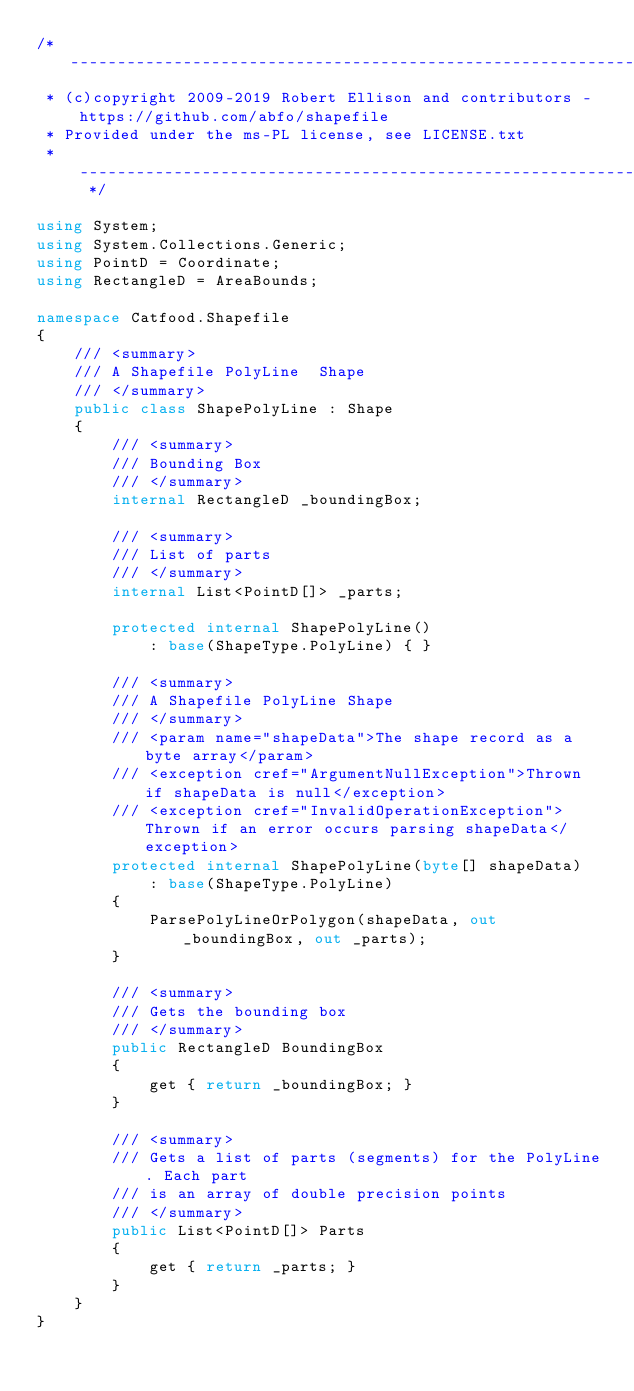Convert code to text. <code><loc_0><loc_0><loc_500><loc_500><_C#_>/* ------------------------------------------------------------------------
 * (c)copyright 2009-2019 Robert Ellison and contributors - https://github.com/abfo/shapefile
 * Provided under the ms-PL license, see LICENSE.txt
 * ------------------------------------------------------------------------ */

using System;
using System.Collections.Generic;
using PointD = Coordinate;
using RectangleD = AreaBounds;

namespace Catfood.Shapefile
{
    /// <summary>
    /// A Shapefile PolyLine  Shape
    /// </summary>
    public class ShapePolyLine : Shape
    {
        /// <summary>
        /// Bounding Box
        /// </summary>
        internal RectangleD _boundingBox;

        /// <summary>
        /// List of parts
        /// </summary>
        internal List<PointD[]> _parts;

        protected internal ShapePolyLine()
            : base(ShapeType.PolyLine) { }

        /// <summary>
        /// A Shapefile PolyLine Shape
        /// </summary>
        /// <param name="shapeData">The shape record as a byte array</param>
        /// <exception cref="ArgumentNullException">Thrown if shapeData is null</exception>
        /// <exception cref="InvalidOperationException">Thrown if an error occurs parsing shapeData</exception>
        protected internal ShapePolyLine(byte[] shapeData)
            : base(ShapeType.PolyLine)
        {
            ParsePolyLineOrPolygon(shapeData, out _boundingBox, out _parts);
        }

        /// <summary>
        /// Gets the bounding box
        /// </summary>
        public RectangleD BoundingBox
        {
            get { return _boundingBox; }
        }
        
        /// <summary>
        /// Gets a list of parts (segments) for the PolyLine. Each part
        /// is an array of double precision points
        /// </summary>
        public List<PointD[]> Parts
        {
            get { return _parts; }
        }
    }
}
</code> 